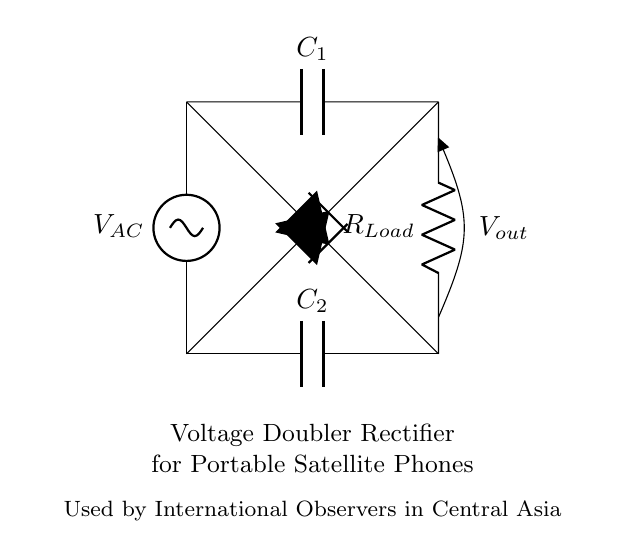What kind of circuit is depicted? The circuit is a voltage doubler rectifier, as indicated by the component arrangement and the function depicted in the title label. Voltage doublers use capacitors and diodes to increase the output voltage.
Answer: Voltage doubler rectifier What are the main components in the circuit? The main components are two capacitors, two diodes, and a load resistor. These components can be identified visually in the circuit, as well as their respective labels.
Answer: Two capacitors, two diodes, load resistor What is the purpose of the diodes in this circuit? The diodes allow current to flow in only one direction, essential for converting alternating current to direct current. Their orientation and connection determine the rectification process, essential for the voltage doubling function.
Answer: Rectification What is the output voltage represented in the circuit? The output voltage is denoted as V out in the diagram, indicating the potential difference available across the load resistor, which will be higher than the input alternating voltage due to the voltage doubling effect.
Answer: V out How does this circuit achieve voltage doubling? The voltage doubling is accomplished through the sequential charging and discharging of the capacitors in conjunction with the diodes, allowing the output voltage to reach approximately twice the peak input voltage during operation.
Answer: By charging capacitors Where is the load connected in this circuit? The load resistor is connected between the two outputs of the diodes and capacitors, allowing it to draw the rectified and doubled voltage. This can be inferred from the connections leading to R Load in the diagram.
Answer: Between the two outputs What role does the capacitor play during operation? The capacitor stores charge during the positive half-cycle of the AC input and releases it during the negative half-cycle, effectively smoothing the output voltage and enabling the voltage doubling feature.
Answer: Charge storage and smoothing 